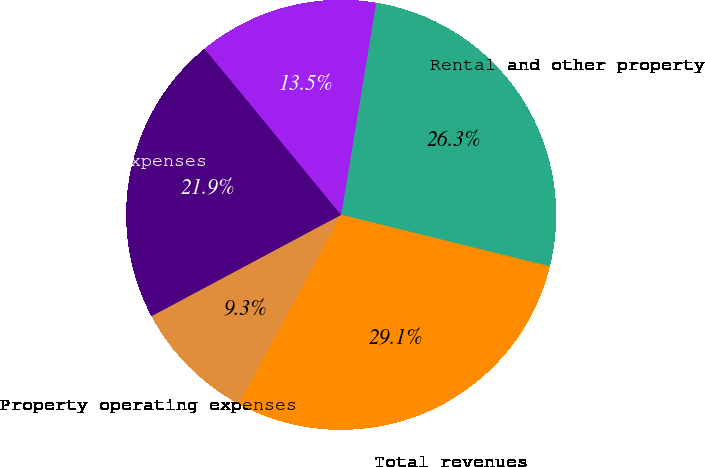<chart> <loc_0><loc_0><loc_500><loc_500><pie_chart><fcel>Rental and other property<fcel>Total revenues<fcel>Property operating expenses<fcel>Total operating expenses<fcel>Income before income tax<nl><fcel>26.26%<fcel>29.06%<fcel>9.28%<fcel>21.86%<fcel>13.55%<nl></chart> 